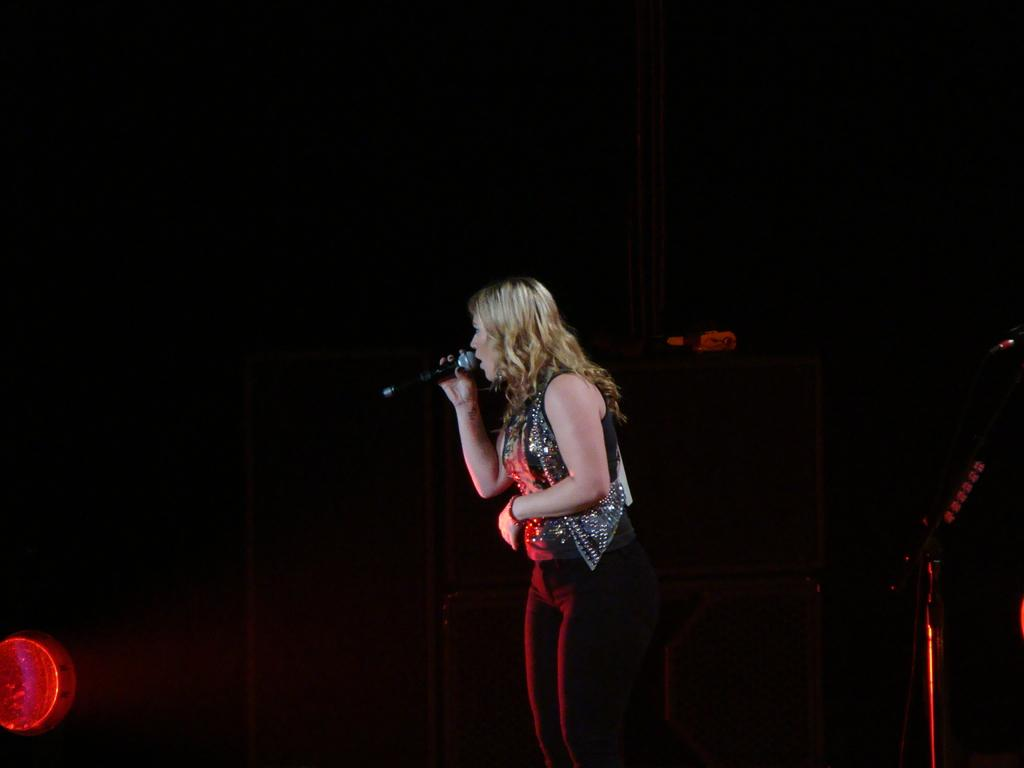Who is the main subject in the image? There is a woman in the image. What is the woman doing in the image? The woman is standing in the image. What object is the woman holding in her hand? The woman is holding a mic in her hand. What type of dinosaurs can be seen in the background of the image? There are no dinosaurs present in the image; it features a woman standing and holding a mic. 